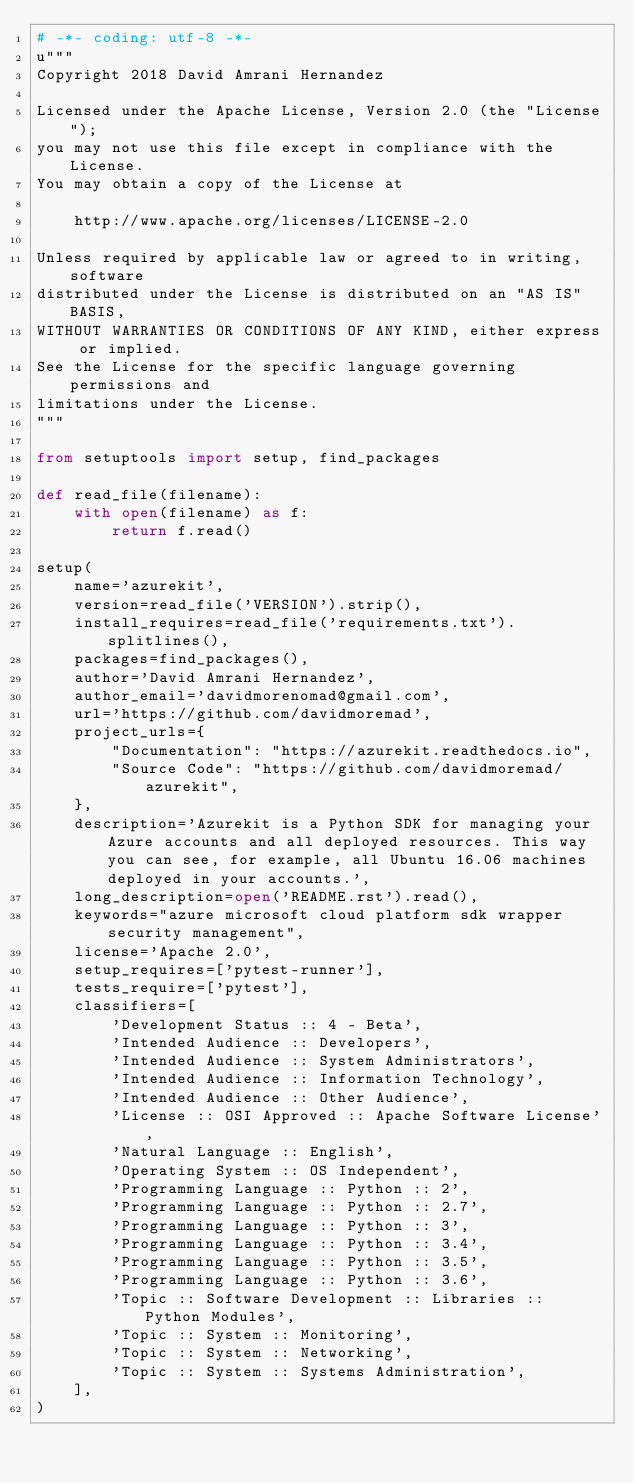<code> <loc_0><loc_0><loc_500><loc_500><_Python_># -*- coding: utf-8 -*-
u"""
Copyright 2018 David Amrani Hernandez

Licensed under the Apache License, Version 2.0 (the "License");
you may not use this file except in compliance with the License.
You may obtain a copy of the License at

    http://www.apache.org/licenses/LICENSE-2.0

Unless required by applicable law or agreed to in writing, software
distributed under the License is distributed on an "AS IS" BASIS,
WITHOUT WARRANTIES OR CONDITIONS OF ANY KIND, either express or implied.
See the License for the specific language governing permissions and
limitations under the License.
"""

from setuptools import setup, find_packages

def read_file(filename):
    with open(filename) as f:
        return f.read()

setup(
    name='azurekit',
    version=read_file('VERSION').strip(),
    install_requires=read_file('requirements.txt').splitlines(),
    packages=find_packages(),
    author='David Amrani Hernandez',
    author_email='davidmorenomad@gmail.com',
    url='https://github.com/davidmoremad',
    project_urls={
        "Documentation": "https://azurekit.readthedocs.io",
        "Source Code": "https://github.com/davidmoremad/azurekit",
    },
    description='Azurekit is a Python SDK for managing your Azure accounts and all deployed resources. This way you can see, for example, all Ubuntu 16.06 machines deployed in your accounts.',
    long_description=open('README.rst').read(),
    keywords="azure microsoft cloud platform sdk wrapper security management",
    license='Apache 2.0',
    setup_requires=['pytest-runner'],
    tests_require=['pytest'],
    classifiers=[
        'Development Status :: 4 - Beta',
        'Intended Audience :: Developers',
        'Intended Audience :: System Administrators',
        'Intended Audience :: Information Technology',
        'Intended Audience :: Other Audience',
        'License :: OSI Approved :: Apache Software License',
        'Natural Language :: English',
        'Operating System :: OS Independent',
        'Programming Language :: Python :: 2',
        'Programming Language :: Python :: 2.7',
        'Programming Language :: Python :: 3',
        'Programming Language :: Python :: 3.4',
        'Programming Language :: Python :: 3.5',
        'Programming Language :: Python :: 3.6',
        'Topic :: Software Development :: Libraries :: Python Modules',
        'Topic :: System :: Monitoring',
        'Topic :: System :: Networking',
        'Topic :: System :: Systems Administration',
    ],
)
</code> 